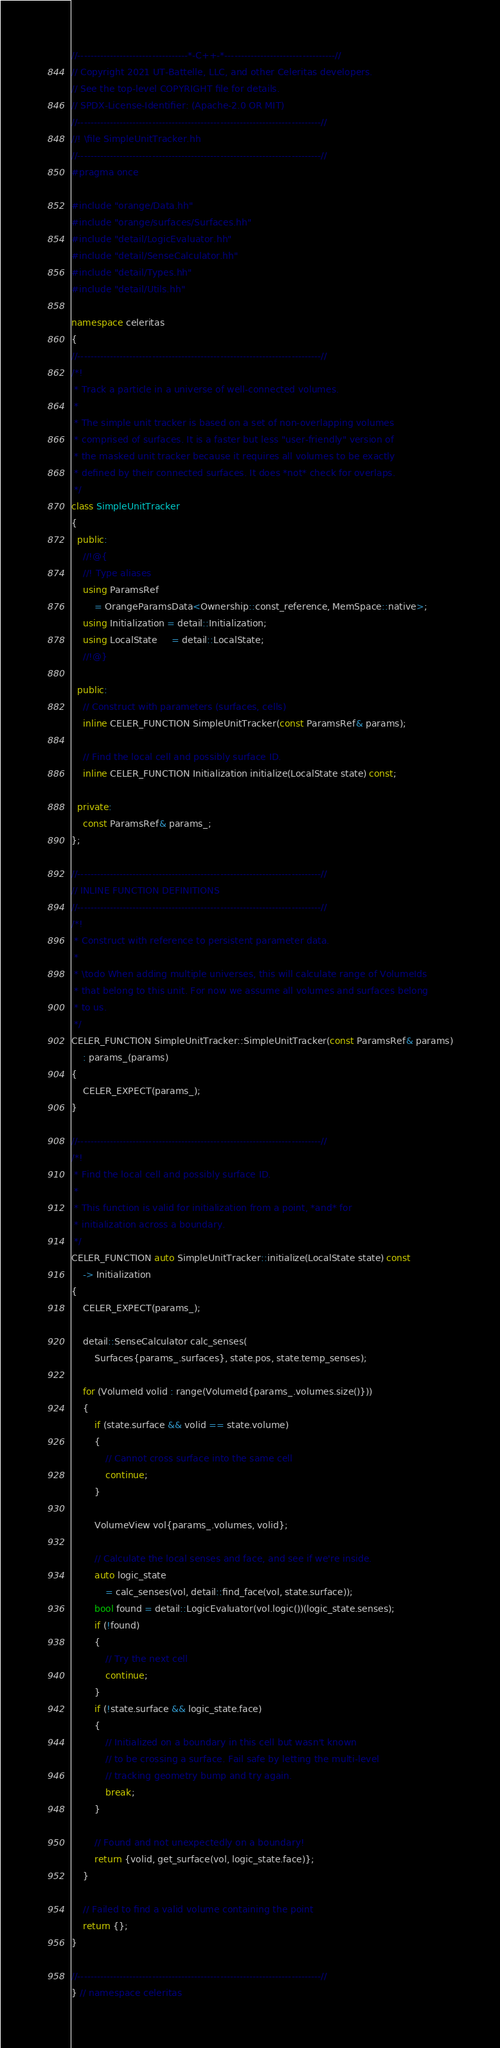<code> <loc_0><loc_0><loc_500><loc_500><_C++_>//----------------------------------*-C++-*----------------------------------//
// Copyright 2021 UT-Battelle, LLC, and other Celeritas developers.
// See the top-level COPYRIGHT file for details.
// SPDX-License-Identifier: (Apache-2.0 OR MIT)
//---------------------------------------------------------------------------//
//! \file SimpleUnitTracker.hh
//---------------------------------------------------------------------------//
#pragma once

#include "orange/Data.hh"
#include "orange/surfaces/Surfaces.hh"
#include "detail/LogicEvaluator.hh"
#include "detail/SenseCalculator.hh"
#include "detail/Types.hh"
#include "detail/Utils.hh"

namespace celeritas
{
//---------------------------------------------------------------------------//
/*!
 * Track a particle in a universe of well-connected volumes.
 *
 * The simple unit tracker is based on a set of non-overlapping volumes
 * comprised of surfaces. It is a faster but less "user-friendly" version of
 * the masked unit tracker because it requires all volumes to be exactly
 * defined by their connected surfaces. It does *not* check for overlaps.
 */
class SimpleUnitTracker
{
  public:
    //!@{
    //! Type aliases
    using ParamsRef
        = OrangeParamsData<Ownership::const_reference, MemSpace::native>;
    using Initialization = detail::Initialization;
    using LocalState     = detail::LocalState;
    //!@}

  public:
    // Construct with parameters (surfaces, cells)
    inline CELER_FUNCTION SimpleUnitTracker(const ParamsRef& params);

    // Find the local cell and possibly surface ID.
    inline CELER_FUNCTION Initialization initialize(LocalState state) const;

  private:
    const ParamsRef& params_;
};

//---------------------------------------------------------------------------//
// INLINE FUNCTION DEFINITIONS
//---------------------------------------------------------------------------//
/*!
 * Construct with reference to persistent parameter data.
 *
 * \todo When adding multiple universes, this will calculate range of VolumeIds
 * that belong to this unit. For now we assume all volumes and surfaces belong
 * to us.
 */
CELER_FUNCTION SimpleUnitTracker::SimpleUnitTracker(const ParamsRef& params)
    : params_(params)
{
    CELER_EXPECT(params_);
}

//---------------------------------------------------------------------------//
/*!
 * Find the local cell and possibly surface ID.
 *
 * This function is valid for initialization from a point, *and* for
 * initialization across a boundary.
 */
CELER_FUNCTION auto SimpleUnitTracker::initialize(LocalState state) const
    -> Initialization
{
    CELER_EXPECT(params_);

    detail::SenseCalculator calc_senses(
        Surfaces{params_.surfaces}, state.pos, state.temp_senses);

    for (VolumeId volid : range(VolumeId{params_.volumes.size()}))
    {
        if (state.surface && volid == state.volume)
        {
            // Cannot cross surface into the same cell
            continue;
        }

        VolumeView vol{params_.volumes, volid};

        // Calculate the local senses and face, and see if we're inside.
        auto logic_state
            = calc_senses(vol, detail::find_face(vol, state.surface));
        bool found = detail::LogicEvaluator(vol.logic())(logic_state.senses);
        if (!found)
        {
            // Try the next cell
            continue;
        }
        if (!state.surface && logic_state.face)
        {
            // Initialized on a boundary in this cell but wasn't known
            // to be crossing a surface. Fail safe by letting the multi-level
            // tracking geometry bump and try again.
            break;
        }

        // Found and not unexpectedly on a boundary!
        return {volid, get_surface(vol, logic_state.face)};
    }

    // Failed to find a valid volume containing the point
    return {};
}

//---------------------------------------------------------------------------//
} // namespace celeritas
</code> 